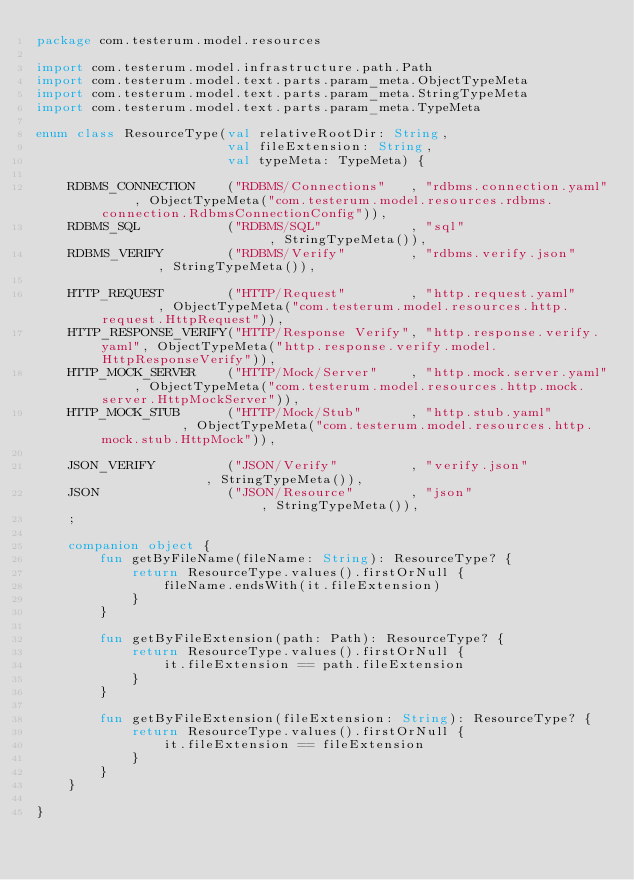<code> <loc_0><loc_0><loc_500><loc_500><_Kotlin_>package com.testerum.model.resources

import com.testerum.model.infrastructure.path.Path
import com.testerum.model.text.parts.param_meta.ObjectTypeMeta
import com.testerum.model.text.parts.param_meta.StringTypeMeta
import com.testerum.model.text.parts.param_meta.TypeMeta

enum class ResourceType(val relativeRootDir: String,
                        val fileExtension: String,
                        val typeMeta: TypeMeta) {

    RDBMS_CONNECTION    ("RDBMS/Connections"   , "rdbms.connection.yaml"    , ObjectTypeMeta("com.testerum.model.resources.rdbms.connection.RdbmsConnectionConfig")),
    RDBMS_SQL           ("RDBMS/SQL"           , "sql"                      , StringTypeMeta()),
    RDBMS_VERIFY        ("RDBMS/Verify"        , "rdbms.verify.json"        , StringTypeMeta()),

    HTTP_REQUEST        ("HTTP/Request"        , "http.request.yaml"        , ObjectTypeMeta("com.testerum.model.resources.http.request.HttpRequest")),
    HTTP_RESPONSE_VERIFY("HTTP/Response Verify", "http.response.verify.yaml", ObjectTypeMeta("http.response.verify.model.HttpResponseVerify")),
    HTTP_MOCK_SERVER    ("HTTP/Mock/Server"    , "http.mock.server.yaml"    , ObjectTypeMeta("com.testerum.model.resources.http.mock.server.HttpMockServer")),
    HTTP_MOCK_STUB      ("HTTP/Mock/Stub"      , "http.stub.yaml"           , ObjectTypeMeta("com.testerum.model.resources.http.mock.stub.HttpMock")),

    JSON_VERIFY         ("JSON/Verify"         , "verify.json"              , StringTypeMeta()),
    JSON                ("JSON/Resource"       , "json"                     , StringTypeMeta()),
    ;

    companion object {
        fun getByFileName(fileName: String): ResourceType? {
            return ResourceType.values().firstOrNull {
                fileName.endsWith(it.fileExtension)
            }
        }

        fun getByFileExtension(path: Path): ResourceType? {
            return ResourceType.values().firstOrNull {
                it.fileExtension == path.fileExtension
            }
        }

        fun getByFileExtension(fileExtension: String): ResourceType? {
            return ResourceType.values().firstOrNull {
                it.fileExtension == fileExtension
            }
        }
    }

}
</code> 